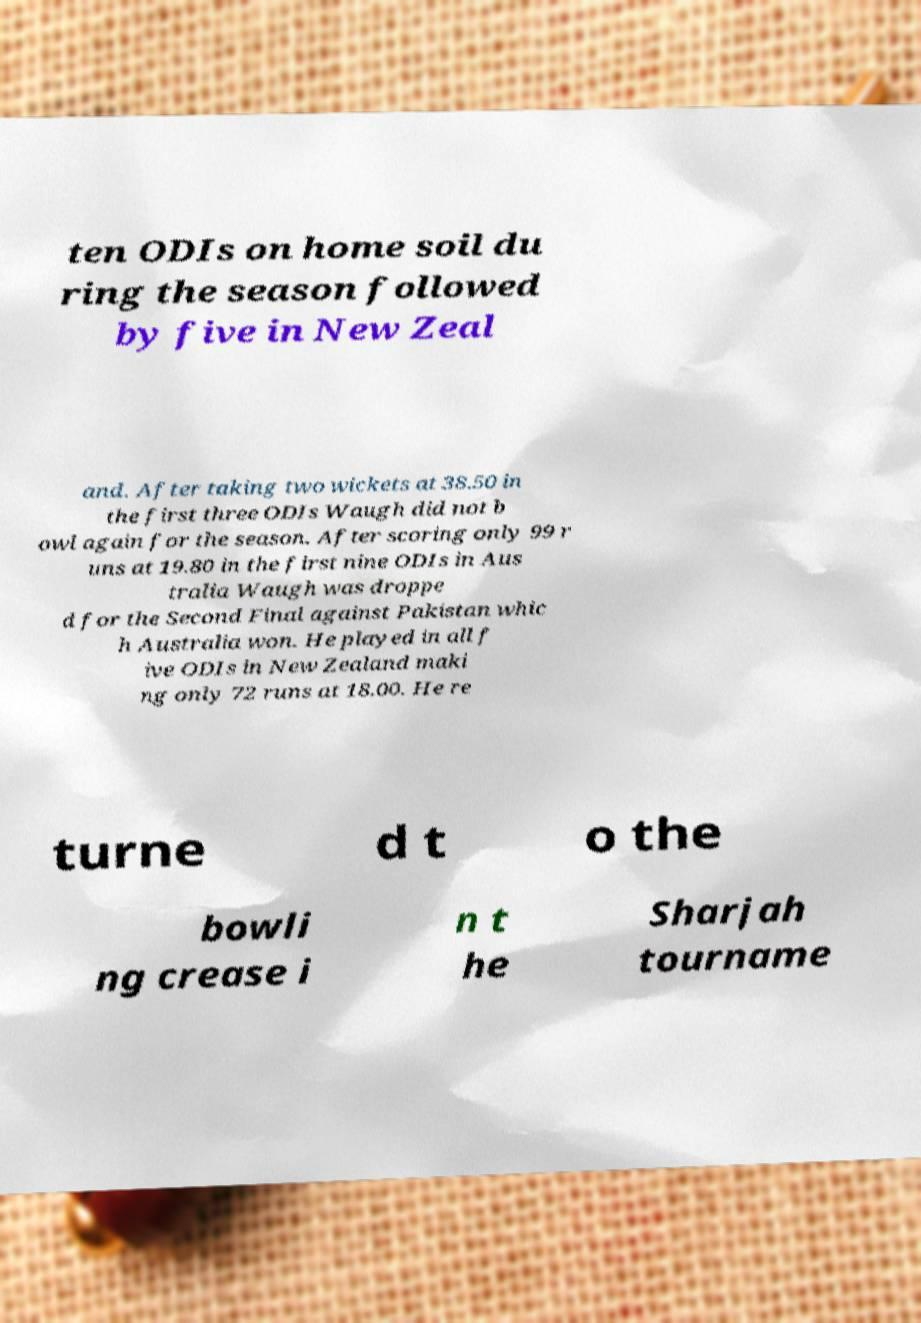I need the written content from this picture converted into text. Can you do that? ten ODIs on home soil du ring the season followed by five in New Zeal and. After taking two wickets at 38.50 in the first three ODIs Waugh did not b owl again for the season. After scoring only 99 r uns at 19.80 in the first nine ODIs in Aus tralia Waugh was droppe d for the Second Final against Pakistan whic h Australia won. He played in all f ive ODIs in New Zealand maki ng only 72 runs at 18.00. He re turne d t o the bowli ng crease i n t he Sharjah tourname 